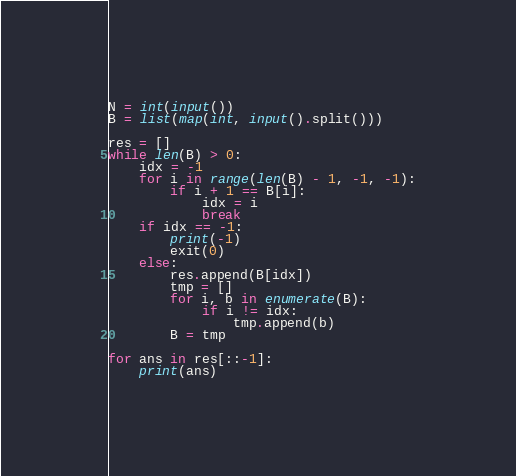Convert code to text. <code><loc_0><loc_0><loc_500><loc_500><_Python_>N = int(input())
B = list(map(int, input().split()))

res = []
while len(B) > 0:
    idx = -1
    for i in range(len(B) - 1, -1, -1):
        if i + 1 == B[i]:
            idx = i
            break
    if idx == -1:
        print(-1)
        exit(0)
    else:
        res.append(B[idx])
        tmp = []
        for i, b in enumerate(B):
            if i != idx:
                tmp.append(b)
        B = tmp

for ans in res[::-1]:
    print(ans)
</code> 